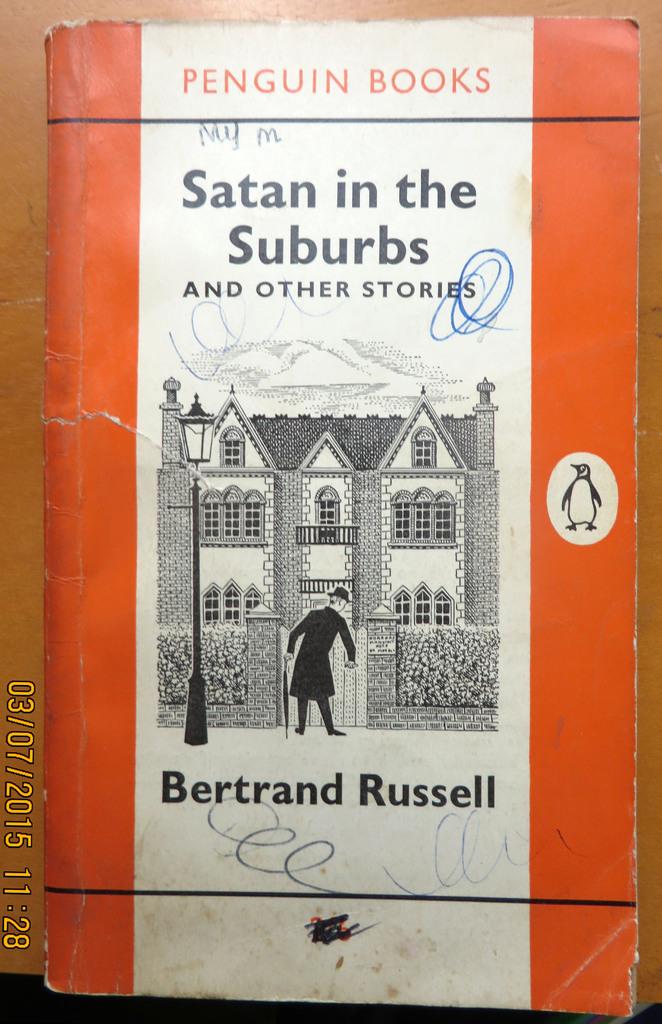What is the title of the book?
Provide a short and direct response. Satan in the suburbs and other stories. Who is the author of the book?
Ensure brevity in your answer.  Bertrand russell. 